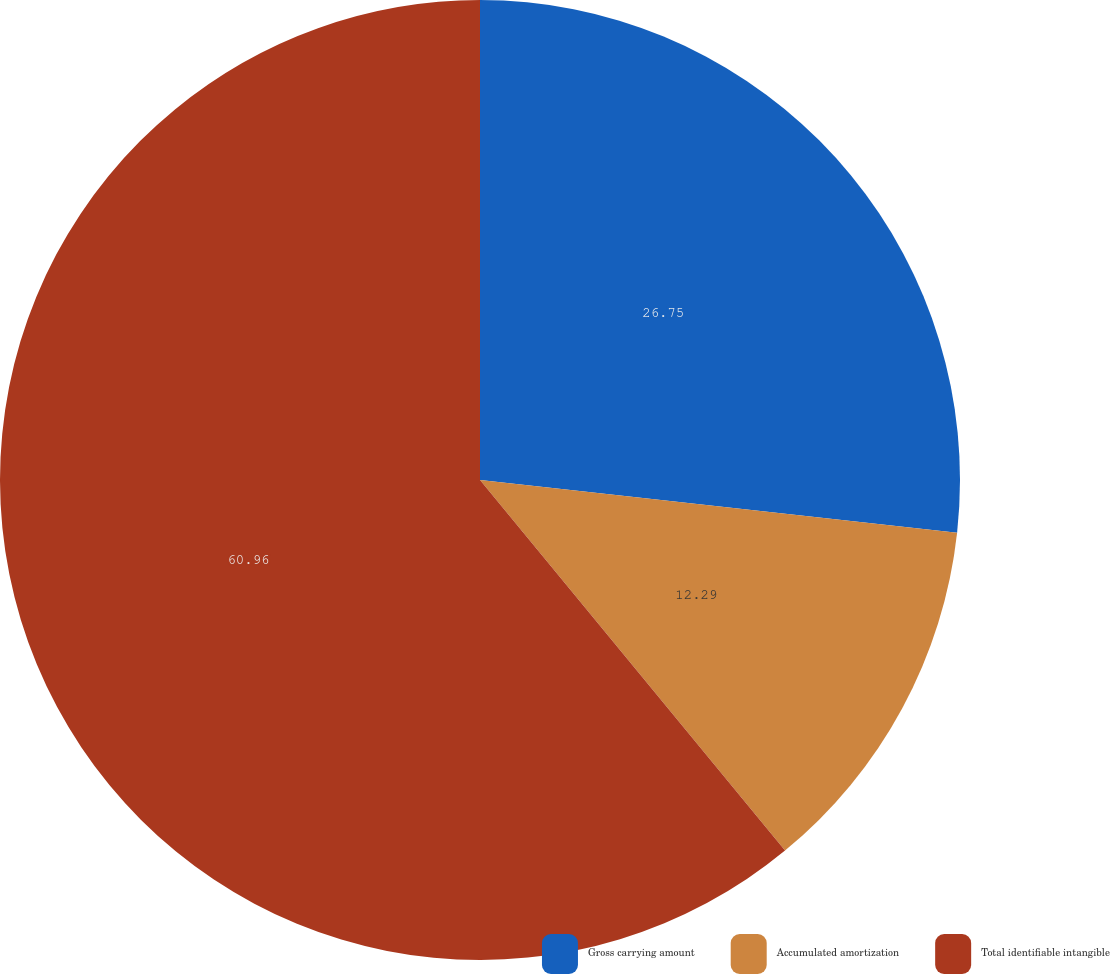Convert chart. <chart><loc_0><loc_0><loc_500><loc_500><pie_chart><fcel>Gross carrying amount<fcel>Accumulated amortization<fcel>Total identifiable intangible<nl><fcel>26.75%<fcel>12.29%<fcel>60.96%<nl></chart> 